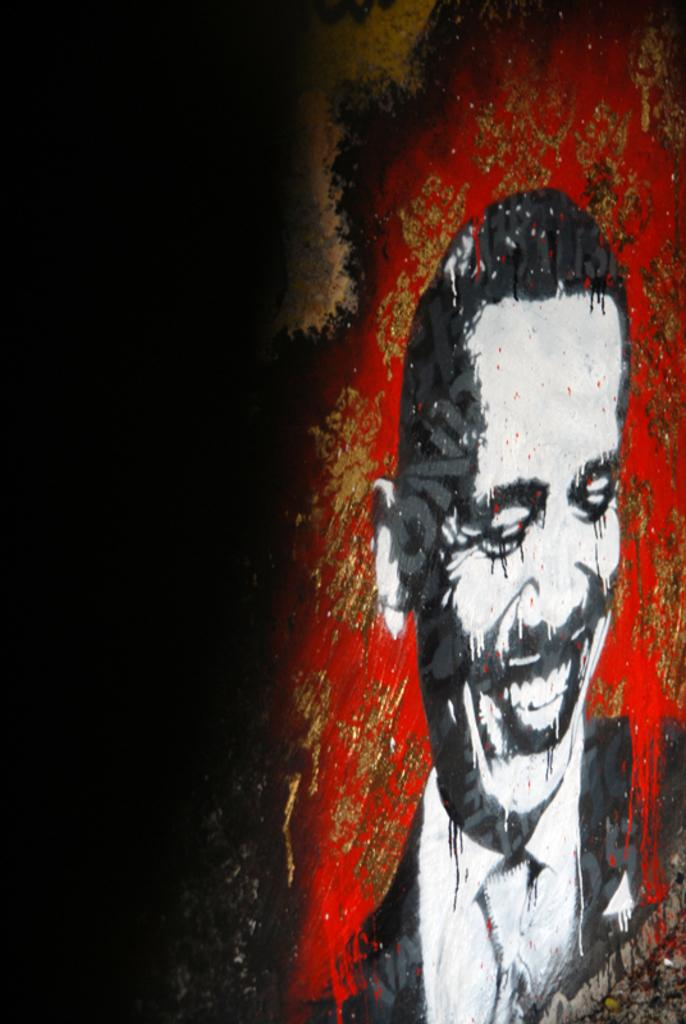What is depicted in the image? There is a painting in the image. What is the subject of the painting? The painting is of a person. Where is the painting located? The painting is on a wall. What type of bun is the person holding in the painting? There is no bun present in the painting; it is a person, not a baker or someone holding a bun. 